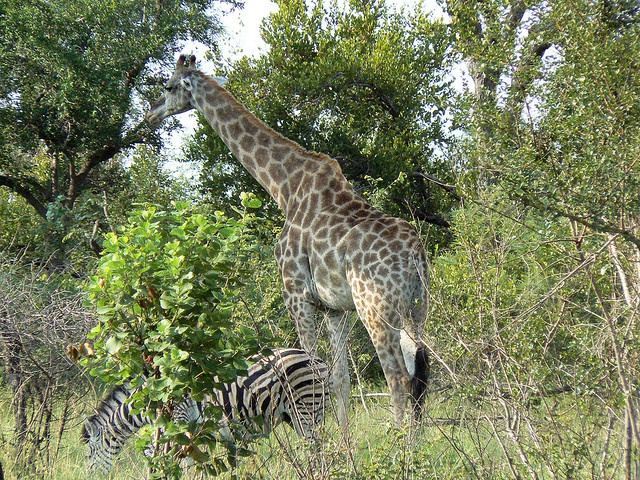Describe the objects in this image and their specific colors. I can see giraffe in green, gray, darkgray, and darkgreen tones, zebra in green, black, gray, darkgray, and olive tones, and zebra in green, darkgray, olive, gray, and khaki tones in this image. 